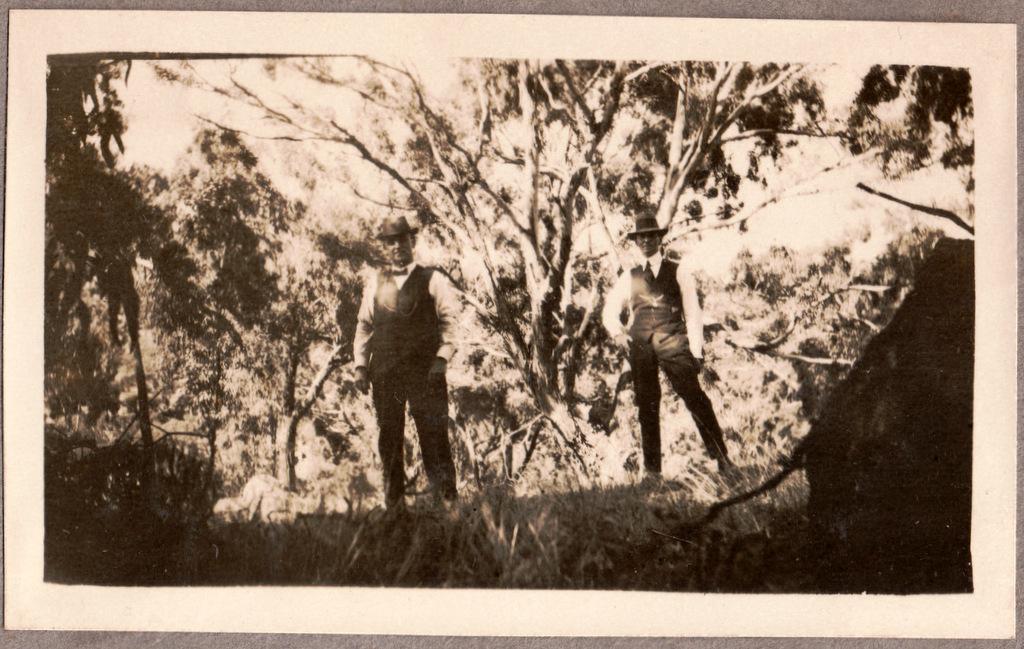Can you describe this image briefly? As we can see in the image there are trees, grass and two people wearing black color hats and black color jackets. 